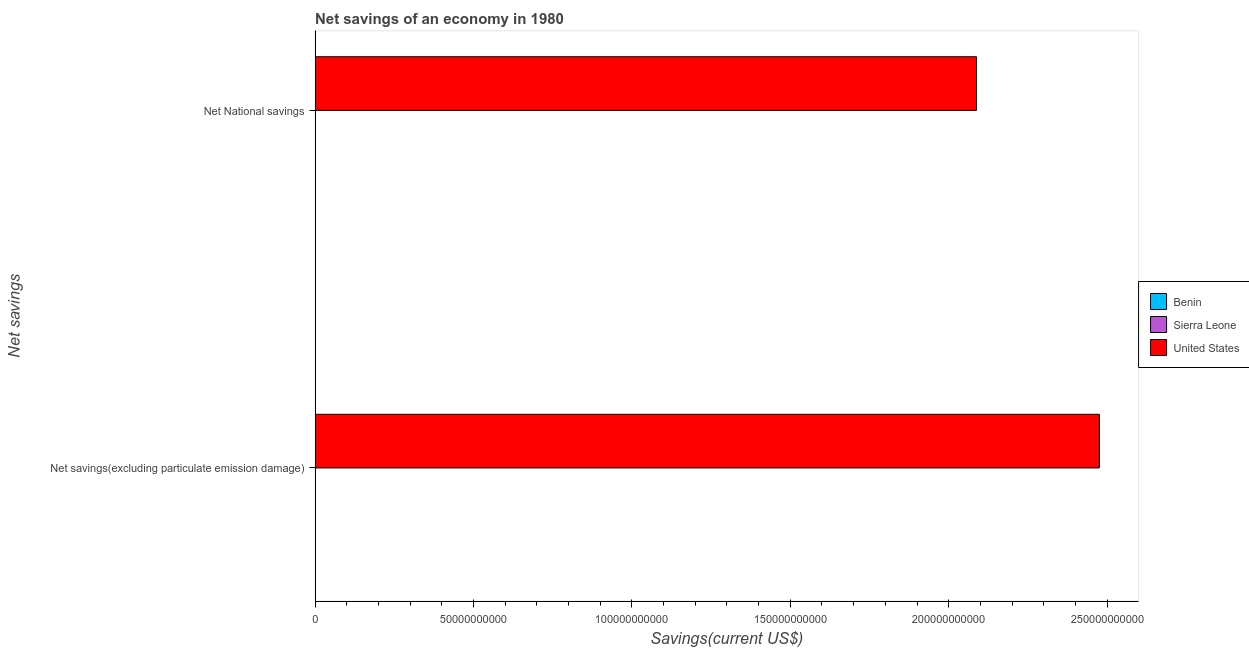Are the number of bars on each tick of the Y-axis equal?
Keep it short and to the point. No. How many bars are there on the 1st tick from the top?
Your response must be concise. 1. What is the label of the 2nd group of bars from the top?
Make the answer very short. Net savings(excluding particulate emission damage). What is the net national savings in Benin?
Your answer should be compact. 0. Across all countries, what is the maximum net savings(excluding particulate emission damage)?
Your answer should be very brief. 2.48e+11. Across all countries, what is the minimum net savings(excluding particulate emission damage)?
Offer a very short reply. 0. What is the total net national savings in the graph?
Offer a terse response. 2.09e+11. What is the difference between the net savings(excluding particulate emission damage) in United States and that in Benin?
Provide a short and direct response. 2.48e+11. What is the difference between the net savings(excluding particulate emission damage) in Benin and the net national savings in Sierra Leone?
Keep it short and to the point. 1.68e+07. What is the average net national savings per country?
Offer a terse response. 6.96e+1. What is the difference between the net national savings and net savings(excluding particulate emission damage) in United States?
Your answer should be compact. -3.88e+1. In how many countries, is the net savings(excluding particulate emission damage) greater than 240000000000 US$?
Give a very brief answer. 1. What is the ratio of the net savings(excluding particulate emission damage) in United States to that in Benin?
Your answer should be very brief. 1.48e+04. In how many countries, is the net savings(excluding particulate emission damage) greater than the average net savings(excluding particulate emission damage) taken over all countries?
Ensure brevity in your answer.  1. How many bars are there?
Your answer should be compact. 3. Are all the bars in the graph horizontal?
Your answer should be very brief. Yes. What is the difference between two consecutive major ticks on the X-axis?
Your answer should be very brief. 5.00e+1. Does the graph contain any zero values?
Provide a succinct answer. Yes. Where does the legend appear in the graph?
Your answer should be compact. Center right. How many legend labels are there?
Your answer should be compact. 3. How are the legend labels stacked?
Keep it short and to the point. Vertical. What is the title of the graph?
Provide a short and direct response. Net savings of an economy in 1980. Does "Kazakhstan" appear as one of the legend labels in the graph?
Offer a terse response. No. What is the label or title of the X-axis?
Offer a very short reply. Savings(current US$). What is the label or title of the Y-axis?
Provide a succinct answer. Net savings. What is the Savings(current US$) of Benin in Net savings(excluding particulate emission damage)?
Offer a very short reply. 1.68e+07. What is the Savings(current US$) of Sierra Leone in Net savings(excluding particulate emission damage)?
Your response must be concise. 0. What is the Savings(current US$) of United States in Net savings(excluding particulate emission damage)?
Your response must be concise. 2.48e+11. What is the Savings(current US$) of Benin in Net National savings?
Your answer should be compact. 0. What is the Savings(current US$) in Sierra Leone in Net National savings?
Keep it short and to the point. 0. What is the Savings(current US$) in United States in Net National savings?
Offer a very short reply. 2.09e+11. Across all Net savings, what is the maximum Savings(current US$) in Benin?
Your answer should be compact. 1.68e+07. Across all Net savings, what is the maximum Savings(current US$) of United States?
Your answer should be compact. 2.48e+11. Across all Net savings, what is the minimum Savings(current US$) in United States?
Keep it short and to the point. 2.09e+11. What is the total Savings(current US$) in Benin in the graph?
Ensure brevity in your answer.  1.68e+07. What is the total Savings(current US$) of United States in the graph?
Offer a terse response. 4.56e+11. What is the difference between the Savings(current US$) in United States in Net savings(excluding particulate emission damage) and that in Net National savings?
Offer a very short reply. 3.88e+1. What is the difference between the Savings(current US$) of Benin in Net savings(excluding particulate emission damage) and the Savings(current US$) of United States in Net National savings?
Your answer should be very brief. -2.09e+11. What is the average Savings(current US$) of Benin per Net savings?
Provide a succinct answer. 8.39e+06. What is the average Savings(current US$) of Sierra Leone per Net savings?
Ensure brevity in your answer.  0. What is the average Savings(current US$) of United States per Net savings?
Give a very brief answer. 2.28e+11. What is the difference between the Savings(current US$) of Benin and Savings(current US$) of United States in Net savings(excluding particulate emission damage)?
Ensure brevity in your answer.  -2.48e+11. What is the ratio of the Savings(current US$) in United States in Net savings(excluding particulate emission damage) to that in Net National savings?
Your response must be concise. 1.19. What is the difference between the highest and the second highest Savings(current US$) of United States?
Give a very brief answer. 3.88e+1. What is the difference between the highest and the lowest Savings(current US$) in Benin?
Your response must be concise. 1.68e+07. What is the difference between the highest and the lowest Savings(current US$) in United States?
Provide a succinct answer. 3.88e+1. 